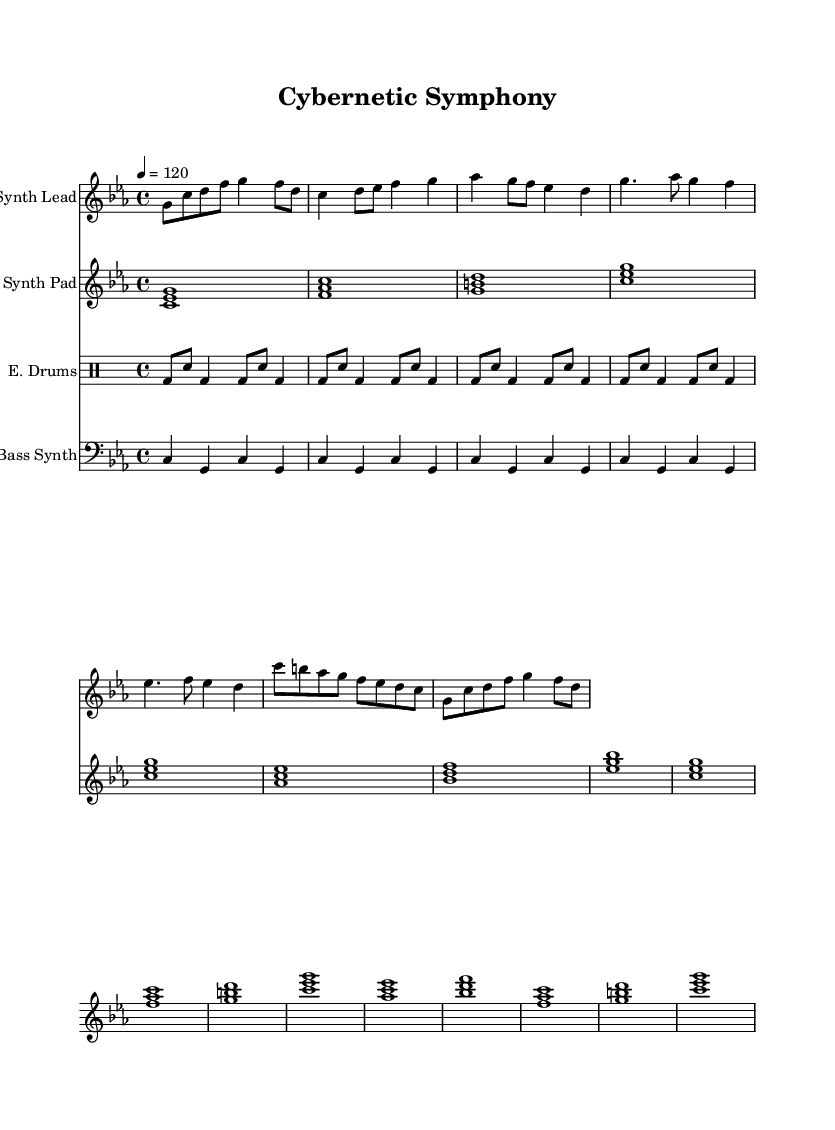What is the key signature of this music? The key signature is indicated by the sharp or flat marks in the beginning of the staff. In this case, there are three flats, suggesting B-flat, E-flat, and A-flat are present in the scale. Therefore, the piece is in C minor.
Answer: C minor What is the time signature of this composition? The time signature is represented by the numbers at the beginning of the score. Here, it shows 4 over 4, which means there are four beats in a measure, with each beat being a quarter note.
Answer: 4/4 What is the tempo marking of this piece? The tempo marking is noted in the score by the number followed by an equals sign. Here it states 4 = 120, which describes the number of beats per minute.
Answer: 120 How many measures are in the "Chorus" section? By counting the individual sections as designated by the repeating patterns in the score, the "Chorus" appears to consist of four measures based on how the music is structured in the score layout.
Answer: 4 What instrument plays the lead melody? The lead melody is specified at the top of the respective staff. The title indicates that the "Synth Lead" is the instrument designated to play this part.
Answer: Synth Lead What is the role of the "Synth Pad" in the composition? The "Synth Pad" plays sustained chords that provide harmonic support throughout the piece, as indicated by the chord symbols and the notation in the respective staff.
Answer: Harmonic support How does the electronic drums' rhythm pattern change throughout the piece? The electronic drums maintain a consistent rhythm pattern throughout the score, providing a steady drum beat that does not vary across sections. The notation indicates a basic groove with bass and snare alternations.
Answer: Consistent 